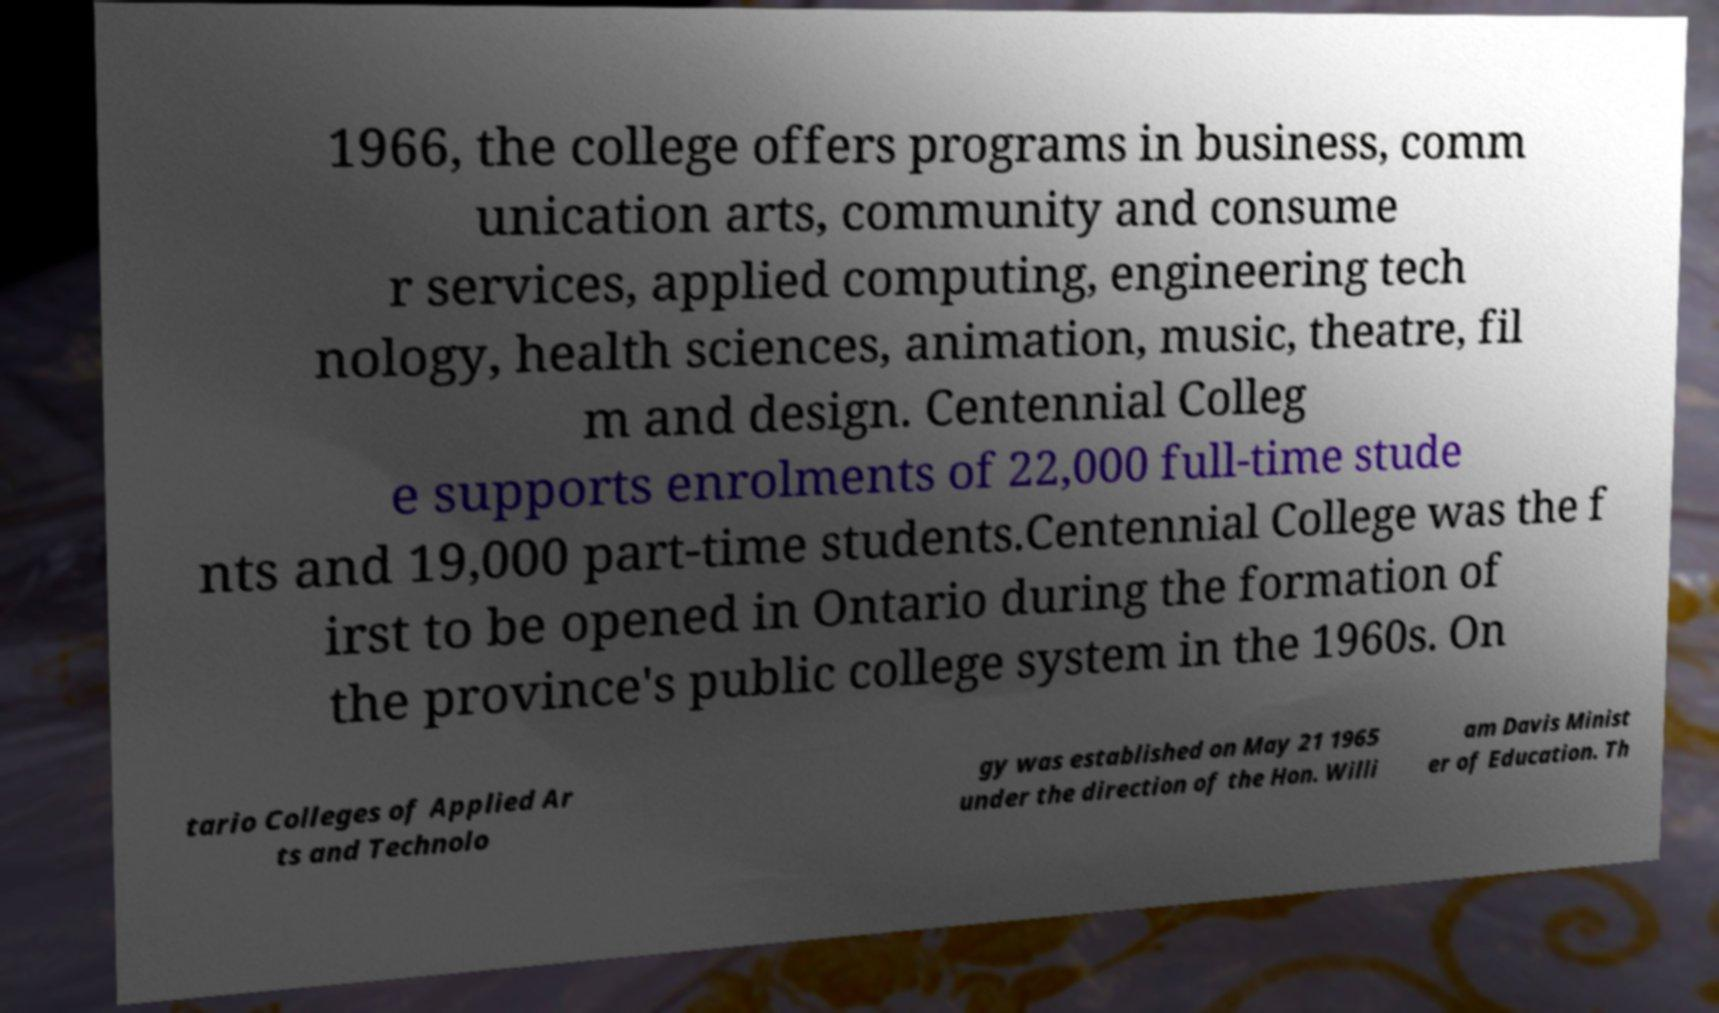There's text embedded in this image that I need extracted. Can you transcribe it verbatim? 1966, the college offers programs in business, comm unication arts, community and consume r services, applied computing, engineering tech nology, health sciences, animation, music, theatre, fil m and design. Centennial Colleg e supports enrolments of 22,000 full-time stude nts and 19,000 part-time students.Centennial College was the f irst to be opened in Ontario during the formation of the province's public college system in the 1960s. On tario Colleges of Applied Ar ts and Technolo gy was established on May 21 1965 under the direction of the Hon. Willi am Davis Minist er of Education. Th 